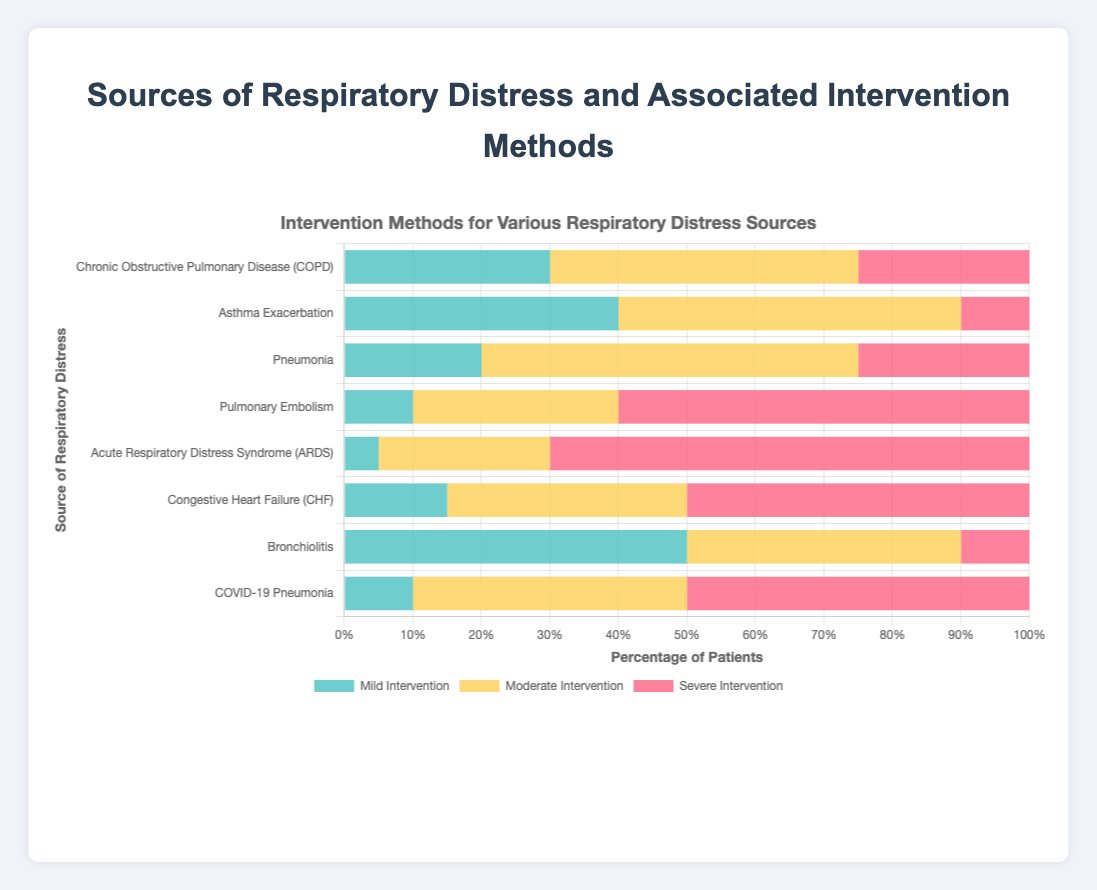What source of respiratory distress requires the highest percentage of severe intervention? The severe intervention percentage is highest for Acute Respiratory Distress Syndrome (ARDS), with 70%.
Answer: ARDS Which source of respiratory distress has the highest percentage of mild intervention? The source with the highest percentage of mild intervention is Bronchiolitis, with 50%.
Answer: Bronchiolitis Compare the moderate intervention percentages of COPD and Pneumonia. Which one is higher? COPD has a moderate intervention percentage of 45%, whereas Pneumonia has 55%. Therefore, Pneumonia's moderate intervention percentage is higher.
Answer: Pneumonia How does the percentage of severe intervention for Pulmonary Embolism compare to COVID-19 Pneumonia? Pulmonary Embolism has a severe intervention percentage of 60%, while COVID-19 Pneumonia has 50%. Thus, Pulmonary Embolism's percentage is higher.
Answer: Pulmonary Embolism What is the combined percentage of mild and moderate interventions for Asthma Exacerbation? Asthma Exacerbation has 40% mild and 50% moderate interventions. Combined, this is 40% + 50% = 90%.
Answer: 90% How does the total percentage of interventions (mild, moderate, severe) for Bronchiolitis compare to CHF? The sum for Bronchiolitis is 50% + 40% + 10% = 100%, and for CHF it is 15% + 35% + 50% = 100%. Both have a total intervention percentage of 100%.
Answer: Equal Which respiratory condition requires the least percentage of severe intervention? Asthma Exacerbation and Bronchiolitis both require the lowest percentage of severe intervention, with 10%.
Answer: Asthma Exacerbation, Bronchiolitis What is the total percentage of interventions needed for pneumonia? Adding all percentages for Pneumonia: 20% mild + 55% moderate + 25% severe = 100%.
Answer: 100% Compare the severe intervention percentages for CHF and ARDS. Which one is higher? ARDS has a severe intervention percentage of 70%, while CHF has 50%. Therefore, ARDS is higher.
Answer: ARDS If you sum the mild interventions for COPD and Pneumonia, what percentage do you get? COPD has 30% and Pneumonia has 20%. The sum is 30% + 20% = 50%.
Answer: 50% 